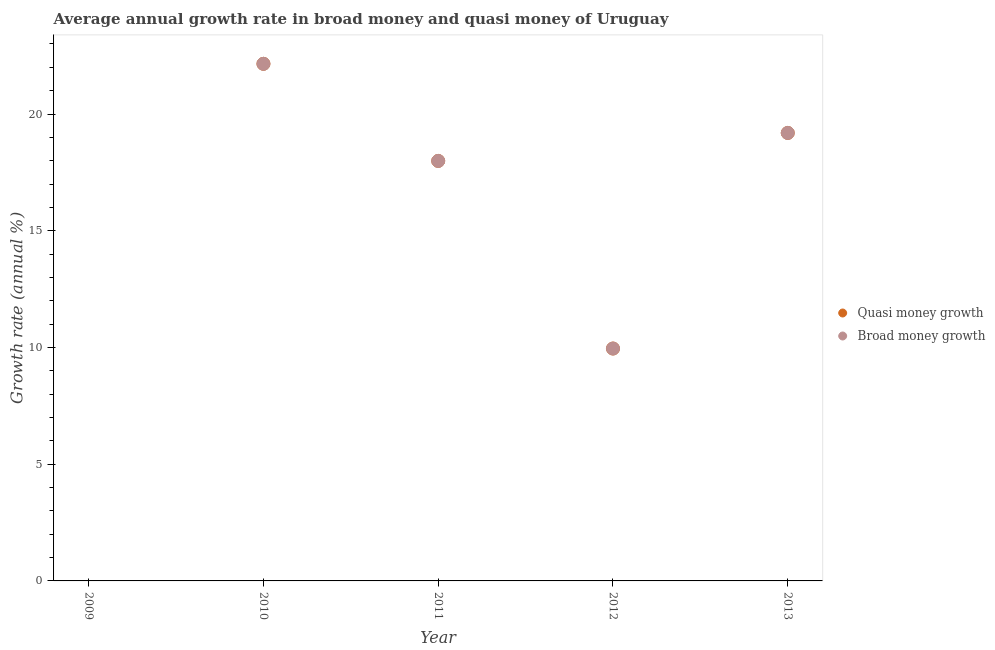Is the number of dotlines equal to the number of legend labels?
Your answer should be very brief. No. Across all years, what is the maximum annual growth rate in quasi money?
Offer a very short reply. 22.15. In which year was the annual growth rate in quasi money maximum?
Make the answer very short. 2010. What is the total annual growth rate in broad money in the graph?
Give a very brief answer. 69.28. What is the difference between the annual growth rate in quasi money in 2010 and that in 2011?
Ensure brevity in your answer.  4.16. What is the difference between the annual growth rate in quasi money in 2010 and the annual growth rate in broad money in 2012?
Offer a terse response. 12.2. What is the average annual growth rate in quasi money per year?
Provide a short and direct response. 13.86. What is the ratio of the annual growth rate in broad money in 2010 to that in 2011?
Make the answer very short. 1.23. Is the annual growth rate in broad money in 2010 less than that in 2012?
Offer a very short reply. No. Is the difference between the annual growth rate in quasi money in 2012 and 2013 greater than the difference between the annual growth rate in broad money in 2012 and 2013?
Your answer should be compact. No. What is the difference between the highest and the second highest annual growth rate in broad money?
Your answer should be compact. 2.96. What is the difference between the highest and the lowest annual growth rate in quasi money?
Ensure brevity in your answer.  22.15. In how many years, is the annual growth rate in quasi money greater than the average annual growth rate in quasi money taken over all years?
Provide a short and direct response. 3. How many years are there in the graph?
Provide a short and direct response. 5. What is the difference between two consecutive major ticks on the Y-axis?
Keep it short and to the point. 5. Are the values on the major ticks of Y-axis written in scientific E-notation?
Provide a succinct answer. No. Does the graph contain any zero values?
Provide a short and direct response. Yes. Where does the legend appear in the graph?
Provide a succinct answer. Center right. How many legend labels are there?
Your answer should be very brief. 2. What is the title of the graph?
Your response must be concise. Average annual growth rate in broad money and quasi money of Uruguay. What is the label or title of the Y-axis?
Ensure brevity in your answer.  Growth rate (annual %). What is the Growth rate (annual %) in Quasi money growth in 2010?
Keep it short and to the point. 22.15. What is the Growth rate (annual %) in Broad money growth in 2010?
Your answer should be very brief. 22.15. What is the Growth rate (annual %) of Quasi money growth in 2011?
Ensure brevity in your answer.  17.99. What is the Growth rate (annual %) of Broad money growth in 2011?
Make the answer very short. 17.99. What is the Growth rate (annual %) in Quasi money growth in 2012?
Offer a terse response. 9.95. What is the Growth rate (annual %) in Broad money growth in 2012?
Your response must be concise. 9.95. What is the Growth rate (annual %) in Quasi money growth in 2013?
Provide a short and direct response. 19.19. What is the Growth rate (annual %) of Broad money growth in 2013?
Make the answer very short. 19.19. Across all years, what is the maximum Growth rate (annual %) in Quasi money growth?
Provide a succinct answer. 22.15. Across all years, what is the maximum Growth rate (annual %) of Broad money growth?
Provide a short and direct response. 22.15. Across all years, what is the minimum Growth rate (annual %) in Broad money growth?
Give a very brief answer. 0. What is the total Growth rate (annual %) of Quasi money growth in the graph?
Keep it short and to the point. 69.28. What is the total Growth rate (annual %) in Broad money growth in the graph?
Make the answer very short. 69.28. What is the difference between the Growth rate (annual %) in Quasi money growth in 2010 and that in 2011?
Make the answer very short. 4.16. What is the difference between the Growth rate (annual %) of Broad money growth in 2010 and that in 2011?
Provide a succinct answer. 4.16. What is the difference between the Growth rate (annual %) in Quasi money growth in 2010 and that in 2012?
Give a very brief answer. 12.2. What is the difference between the Growth rate (annual %) of Broad money growth in 2010 and that in 2012?
Your answer should be compact. 12.2. What is the difference between the Growth rate (annual %) in Quasi money growth in 2010 and that in 2013?
Offer a terse response. 2.96. What is the difference between the Growth rate (annual %) in Broad money growth in 2010 and that in 2013?
Your answer should be very brief. 2.96. What is the difference between the Growth rate (annual %) of Quasi money growth in 2011 and that in 2012?
Provide a short and direct response. 8.04. What is the difference between the Growth rate (annual %) in Broad money growth in 2011 and that in 2012?
Offer a very short reply. 8.04. What is the difference between the Growth rate (annual %) of Quasi money growth in 2011 and that in 2013?
Provide a short and direct response. -1.2. What is the difference between the Growth rate (annual %) of Broad money growth in 2011 and that in 2013?
Your response must be concise. -1.2. What is the difference between the Growth rate (annual %) of Quasi money growth in 2012 and that in 2013?
Ensure brevity in your answer.  -9.24. What is the difference between the Growth rate (annual %) in Broad money growth in 2012 and that in 2013?
Provide a succinct answer. -9.24. What is the difference between the Growth rate (annual %) of Quasi money growth in 2010 and the Growth rate (annual %) of Broad money growth in 2011?
Make the answer very short. 4.16. What is the difference between the Growth rate (annual %) of Quasi money growth in 2010 and the Growth rate (annual %) of Broad money growth in 2012?
Ensure brevity in your answer.  12.2. What is the difference between the Growth rate (annual %) in Quasi money growth in 2010 and the Growth rate (annual %) in Broad money growth in 2013?
Your response must be concise. 2.96. What is the difference between the Growth rate (annual %) in Quasi money growth in 2011 and the Growth rate (annual %) in Broad money growth in 2012?
Your answer should be compact. 8.04. What is the difference between the Growth rate (annual %) in Quasi money growth in 2011 and the Growth rate (annual %) in Broad money growth in 2013?
Offer a terse response. -1.2. What is the difference between the Growth rate (annual %) in Quasi money growth in 2012 and the Growth rate (annual %) in Broad money growth in 2013?
Offer a very short reply. -9.24. What is the average Growth rate (annual %) in Quasi money growth per year?
Your answer should be compact. 13.86. What is the average Growth rate (annual %) of Broad money growth per year?
Keep it short and to the point. 13.86. In the year 2010, what is the difference between the Growth rate (annual %) in Quasi money growth and Growth rate (annual %) in Broad money growth?
Offer a terse response. 0. In the year 2012, what is the difference between the Growth rate (annual %) in Quasi money growth and Growth rate (annual %) in Broad money growth?
Make the answer very short. 0. In the year 2013, what is the difference between the Growth rate (annual %) in Quasi money growth and Growth rate (annual %) in Broad money growth?
Your response must be concise. 0. What is the ratio of the Growth rate (annual %) in Quasi money growth in 2010 to that in 2011?
Your response must be concise. 1.23. What is the ratio of the Growth rate (annual %) of Broad money growth in 2010 to that in 2011?
Provide a succinct answer. 1.23. What is the ratio of the Growth rate (annual %) in Quasi money growth in 2010 to that in 2012?
Provide a succinct answer. 2.23. What is the ratio of the Growth rate (annual %) in Broad money growth in 2010 to that in 2012?
Keep it short and to the point. 2.23. What is the ratio of the Growth rate (annual %) of Quasi money growth in 2010 to that in 2013?
Your answer should be compact. 1.15. What is the ratio of the Growth rate (annual %) of Broad money growth in 2010 to that in 2013?
Ensure brevity in your answer.  1.15. What is the ratio of the Growth rate (annual %) of Quasi money growth in 2011 to that in 2012?
Offer a terse response. 1.81. What is the ratio of the Growth rate (annual %) in Broad money growth in 2011 to that in 2012?
Offer a very short reply. 1.81. What is the ratio of the Growth rate (annual %) of Broad money growth in 2011 to that in 2013?
Ensure brevity in your answer.  0.94. What is the ratio of the Growth rate (annual %) of Quasi money growth in 2012 to that in 2013?
Ensure brevity in your answer.  0.52. What is the ratio of the Growth rate (annual %) in Broad money growth in 2012 to that in 2013?
Provide a short and direct response. 0.52. What is the difference between the highest and the second highest Growth rate (annual %) of Quasi money growth?
Provide a short and direct response. 2.96. What is the difference between the highest and the second highest Growth rate (annual %) of Broad money growth?
Offer a very short reply. 2.96. What is the difference between the highest and the lowest Growth rate (annual %) of Quasi money growth?
Give a very brief answer. 22.15. What is the difference between the highest and the lowest Growth rate (annual %) in Broad money growth?
Provide a short and direct response. 22.15. 